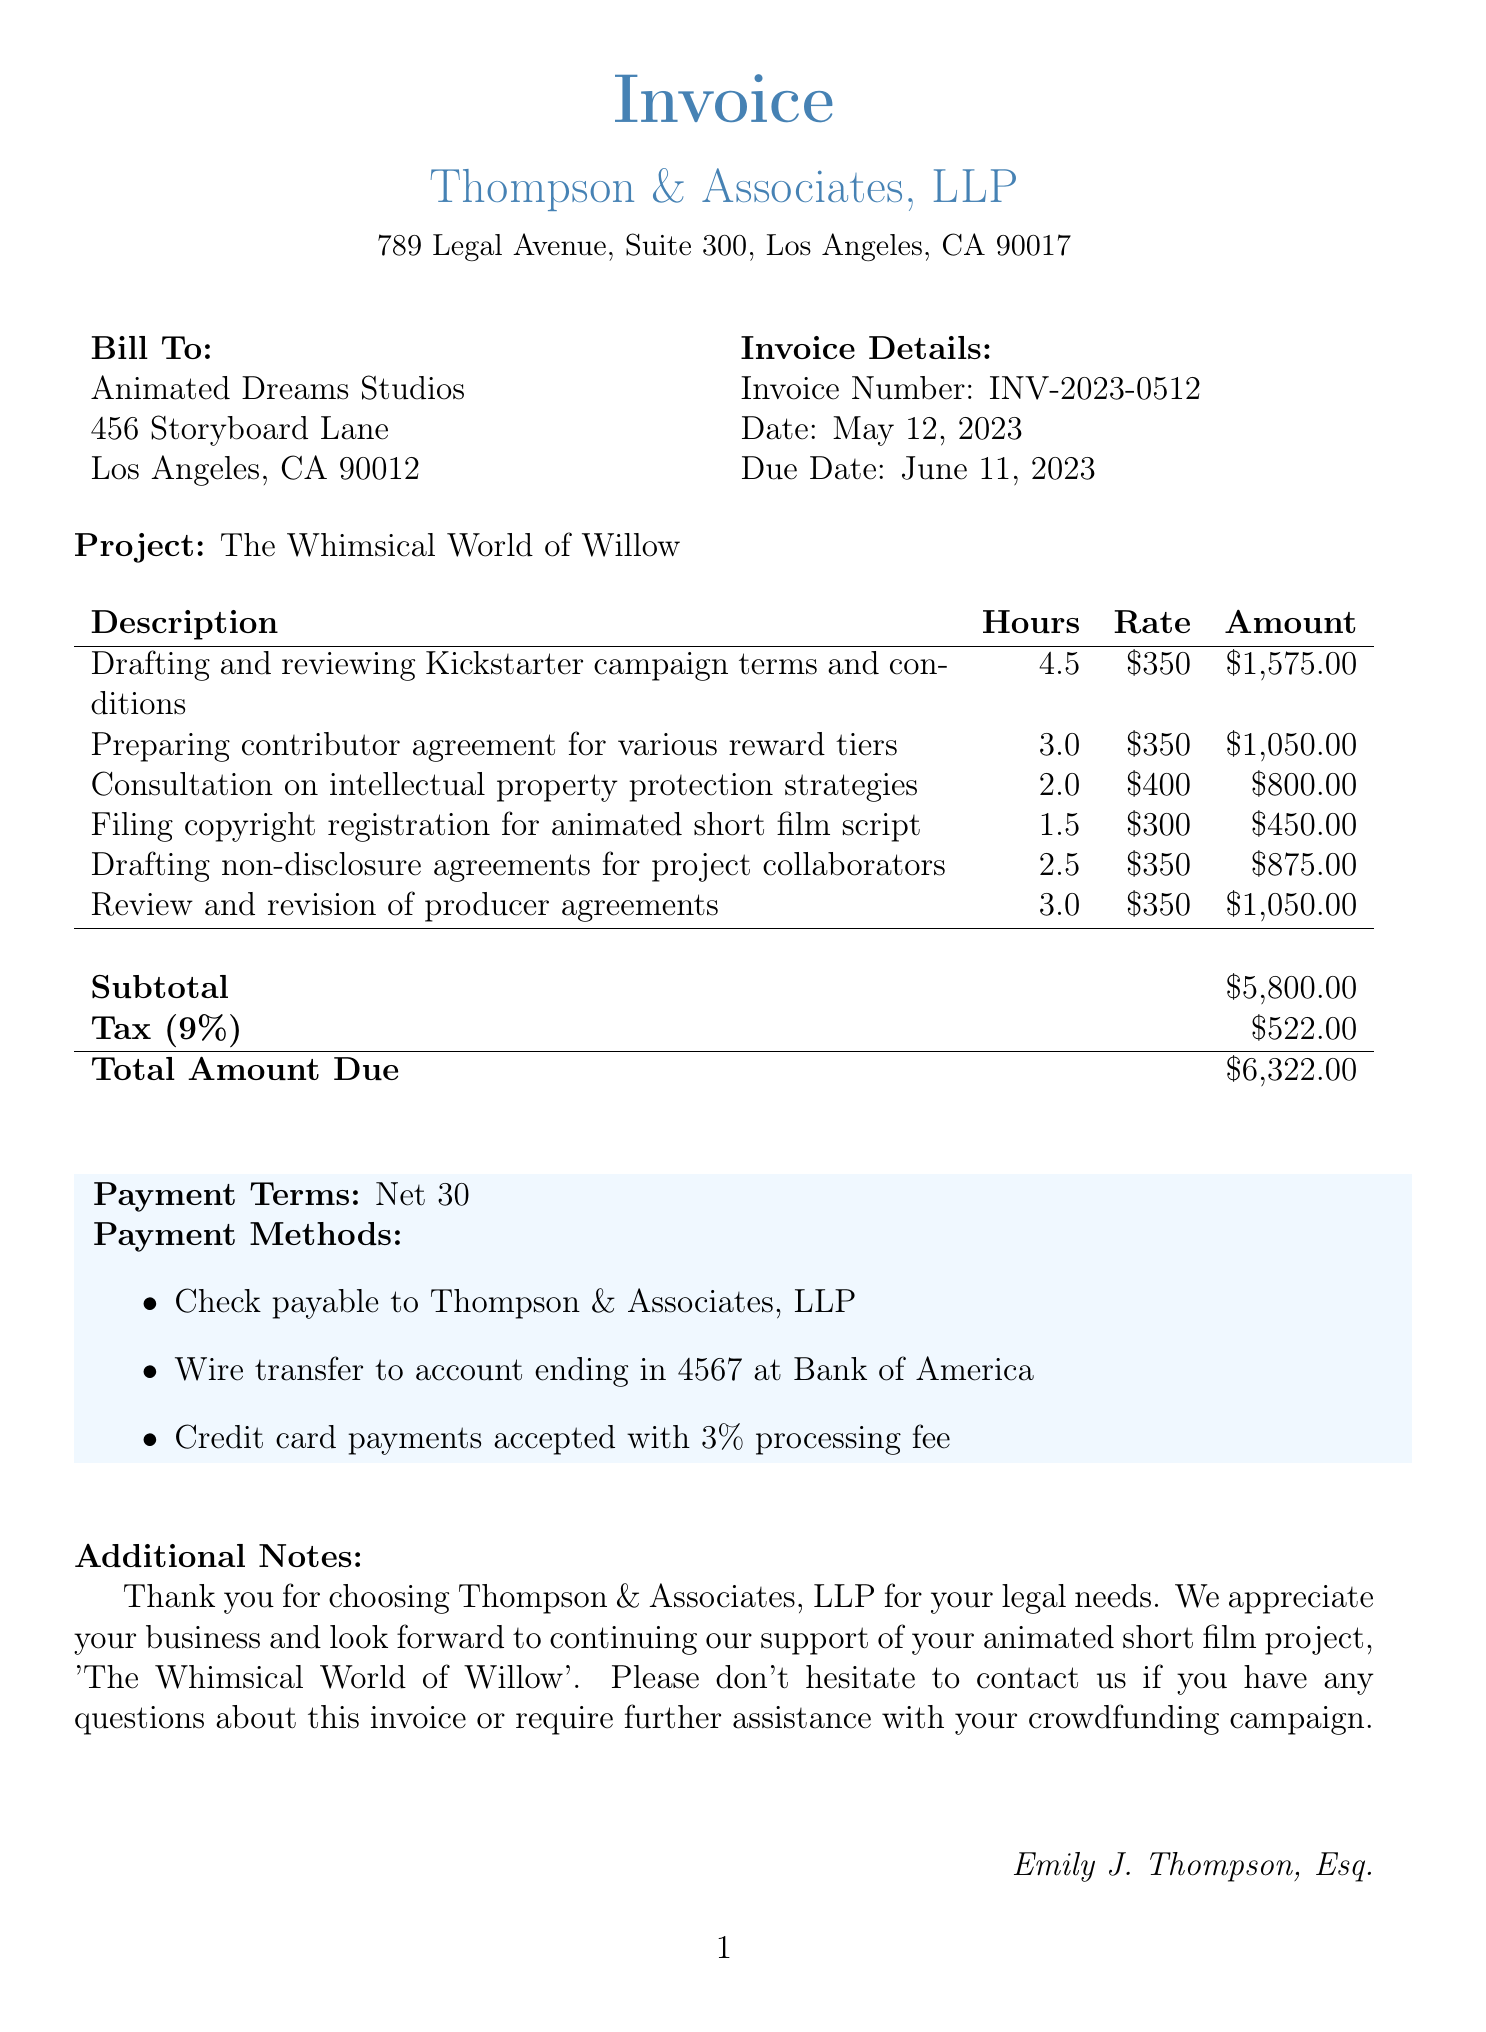what is the invoice number? The invoice number is clearly stated in the document under "Invoice Details."
Answer: INV-2023-0512 who is the attorney handling this invoice? The document specifies the name of the attorney in the signature section at the bottom.
Answer: Emily J. Thompson, Esq what is the total amount due? The total amount is the final figure in the invoice summary, representing the total payable.
Answer: $6,322.00 how many hours were spent drafting and reviewing Kickstarter campaign terms? The number of hours for this specific service is listed in the service description table of the document.
Answer: 4.5 what is the tax rate applied to the invoice? The document mentions the tax rate in the invoice summary, indicating the applicable percentage.
Answer: 9% which project does this invoice pertain to? The project name is stated prominently in the introduction of the invoice.
Answer: The Whimsical World of Willow what is the payment term stated in the invoice? The payment terms detail when the payment is due, found in the payment section of the document.
Answer: Net 30 how many services are listed in the invoice? The total number of services is derived from counting the entries in the services table.
Answer: 6 what additional notes are provided in the invoice? Additional notes are included at the end of the document as a message from the attorney to the client.
Answer: Thank you for choosing Thompson & Associates, LLP for your legal needs 